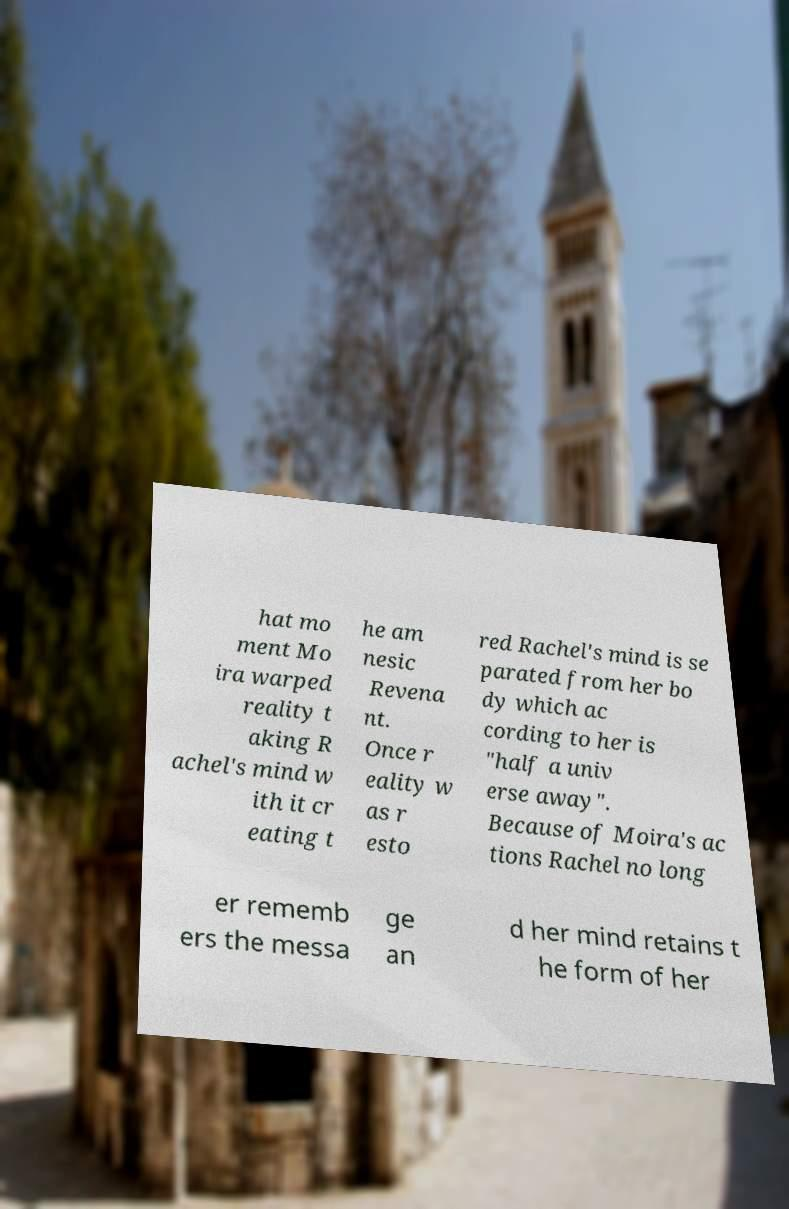Please read and relay the text visible in this image. What does it say? hat mo ment Mo ira warped reality t aking R achel's mind w ith it cr eating t he am nesic Revena nt. Once r eality w as r esto red Rachel's mind is se parated from her bo dy which ac cording to her is "half a univ erse away". Because of Moira's ac tions Rachel no long er rememb ers the messa ge an d her mind retains t he form of her 